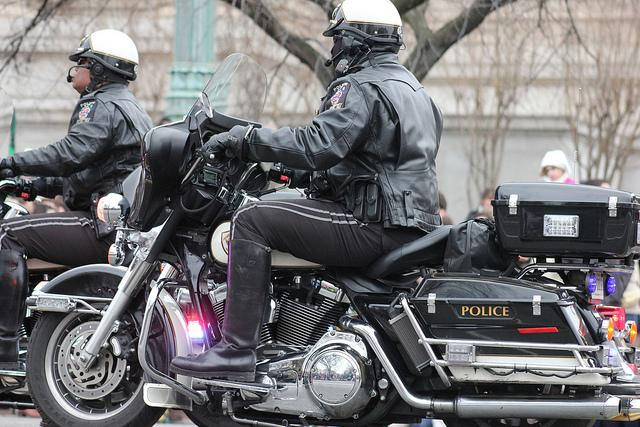What would be one main reason a police would be riding this type of motorcycle? patrol 